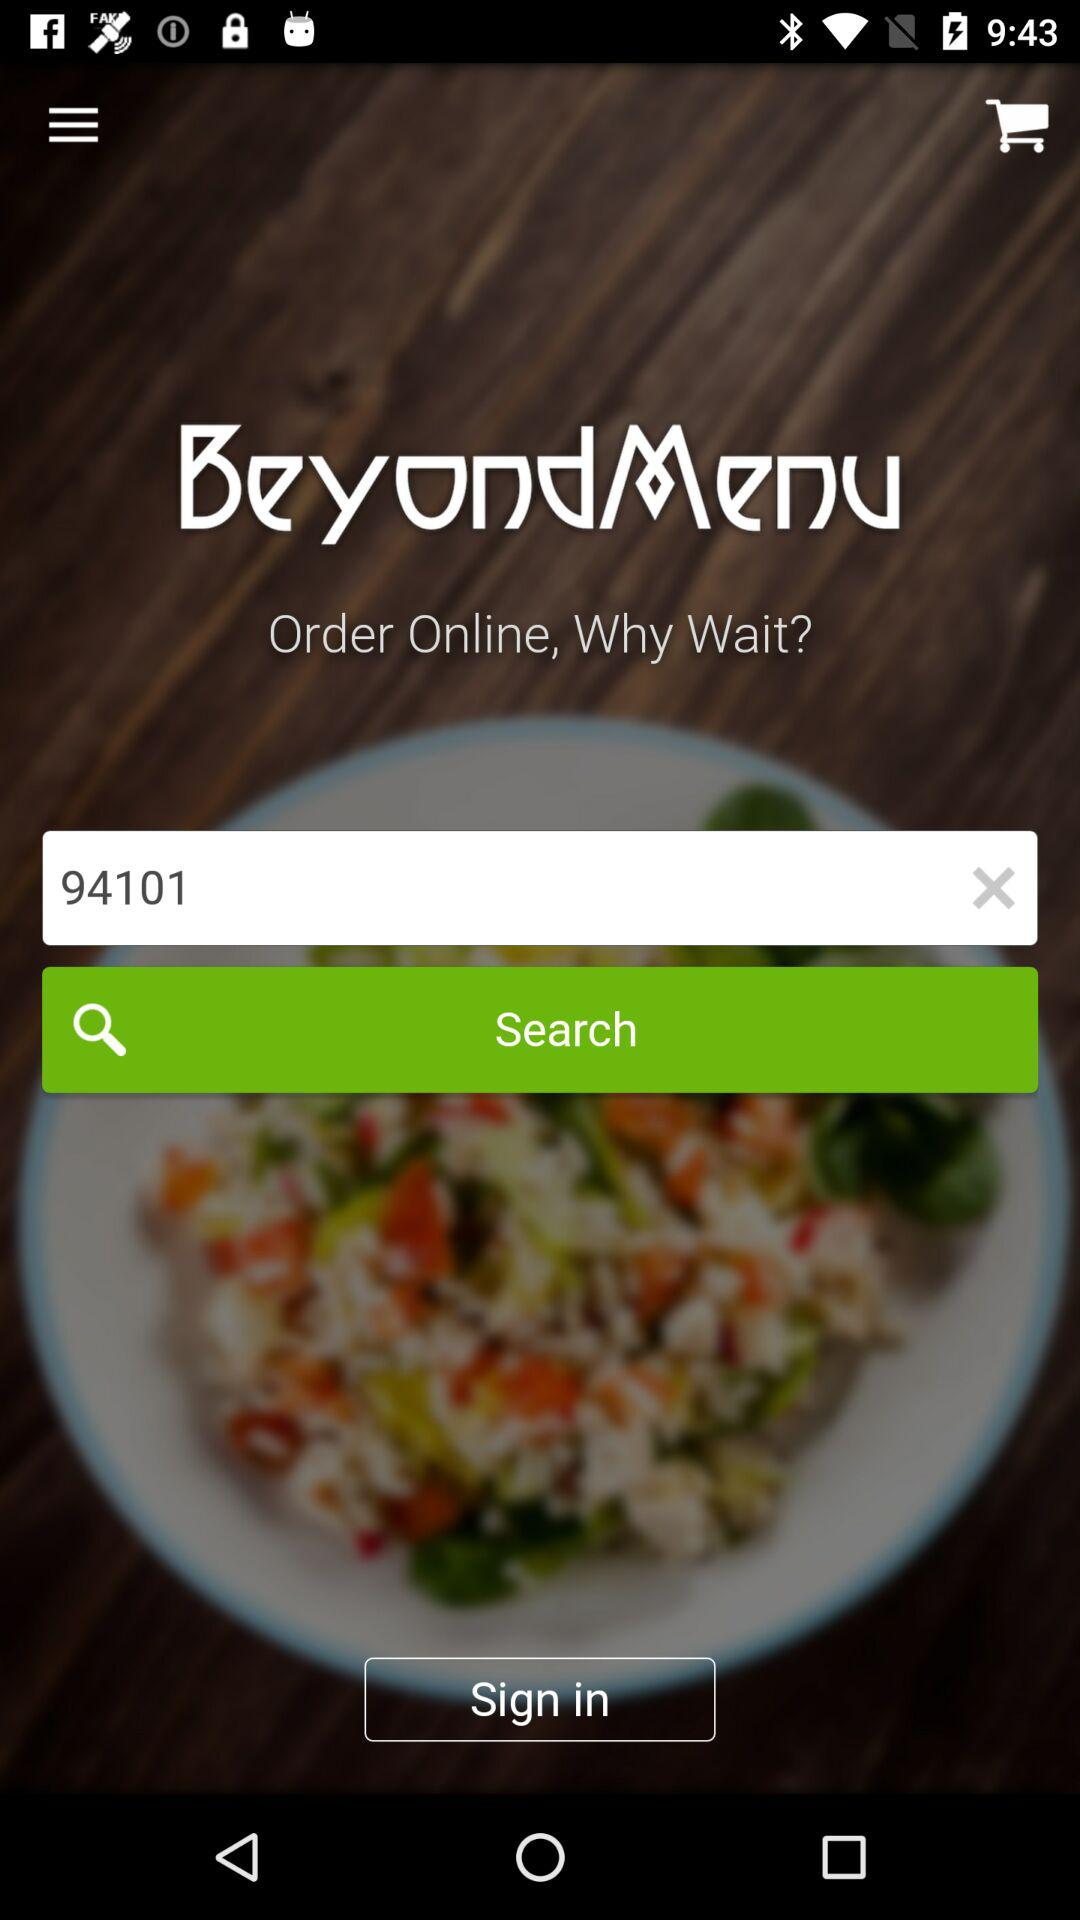What is the pincode? The pin code is 94101. 